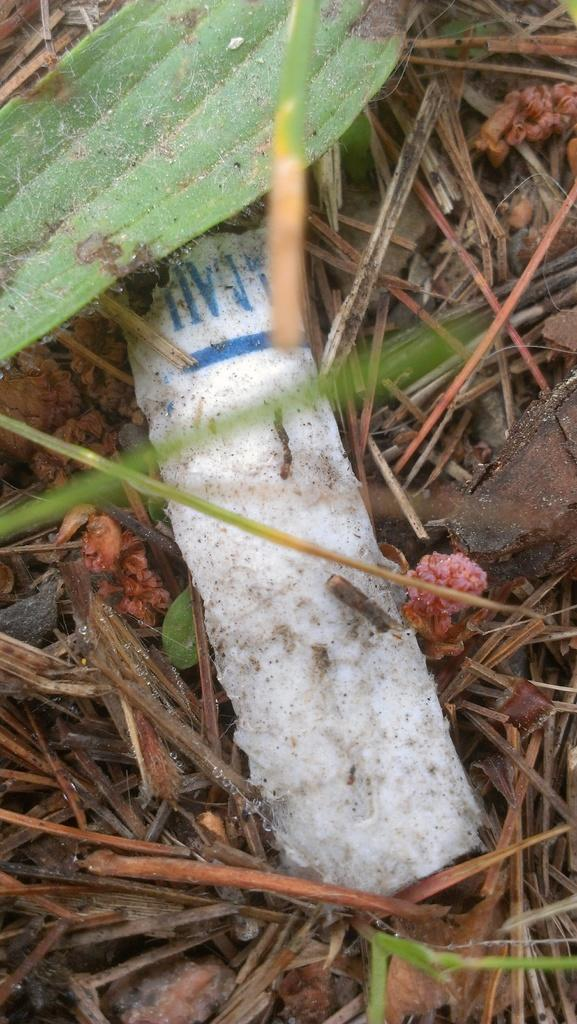What type of vegetation is present in the image? There is grass in the image. What color is the object in the image? The object in the image is white. How many pigs can be seen playing with the father in the image? There are no pigs or a father present in the image; it only features grass and a white object. 